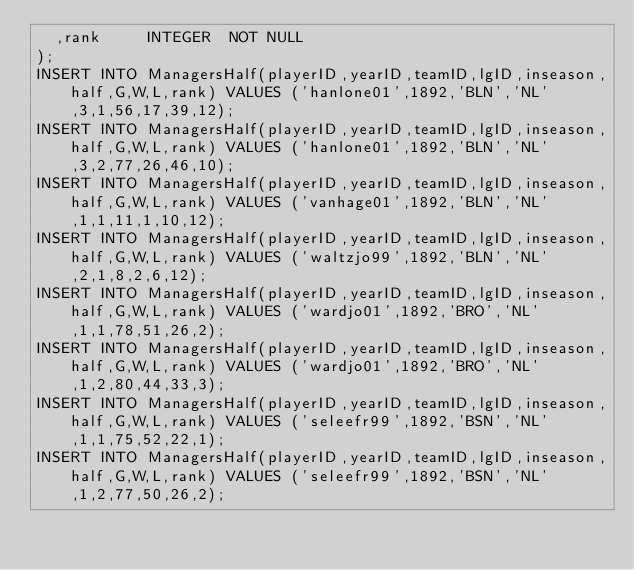Convert code to text. <code><loc_0><loc_0><loc_500><loc_500><_SQL_>  ,rank     INTEGER  NOT NULL
);
INSERT INTO ManagersHalf(playerID,yearID,teamID,lgID,inseason,half,G,W,L,rank) VALUES ('hanlone01',1892,'BLN','NL',3,1,56,17,39,12);
INSERT INTO ManagersHalf(playerID,yearID,teamID,lgID,inseason,half,G,W,L,rank) VALUES ('hanlone01',1892,'BLN','NL',3,2,77,26,46,10);
INSERT INTO ManagersHalf(playerID,yearID,teamID,lgID,inseason,half,G,W,L,rank) VALUES ('vanhage01',1892,'BLN','NL',1,1,11,1,10,12);
INSERT INTO ManagersHalf(playerID,yearID,teamID,lgID,inseason,half,G,W,L,rank) VALUES ('waltzjo99',1892,'BLN','NL',2,1,8,2,6,12);
INSERT INTO ManagersHalf(playerID,yearID,teamID,lgID,inseason,half,G,W,L,rank) VALUES ('wardjo01',1892,'BRO','NL',1,1,78,51,26,2);
INSERT INTO ManagersHalf(playerID,yearID,teamID,lgID,inseason,half,G,W,L,rank) VALUES ('wardjo01',1892,'BRO','NL',1,2,80,44,33,3);
INSERT INTO ManagersHalf(playerID,yearID,teamID,lgID,inseason,half,G,W,L,rank) VALUES ('seleefr99',1892,'BSN','NL',1,1,75,52,22,1);
INSERT INTO ManagersHalf(playerID,yearID,teamID,lgID,inseason,half,G,W,L,rank) VALUES ('seleefr99',1892,'BSN','NL',1,2,77,50,26,2);</code> 